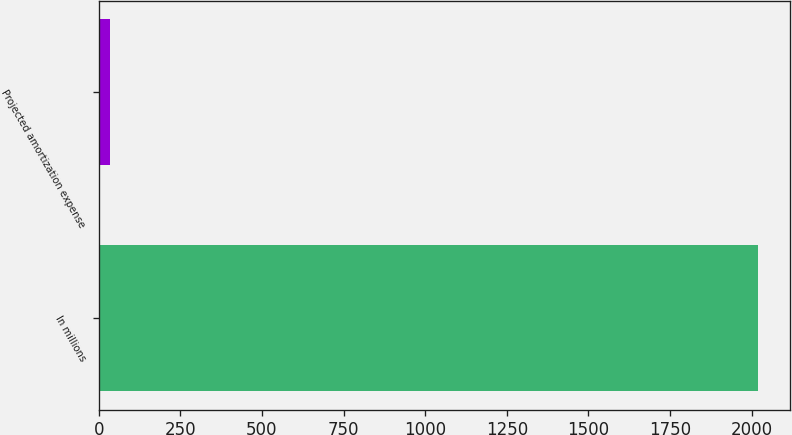Convert chart. <chart><loc_0><loc_0><loc_500><loc_500><bar_chart><fcel>In millions<fcel>Projected amortization expense<nl><fcel>2018<fcel>36<nl></chart> 